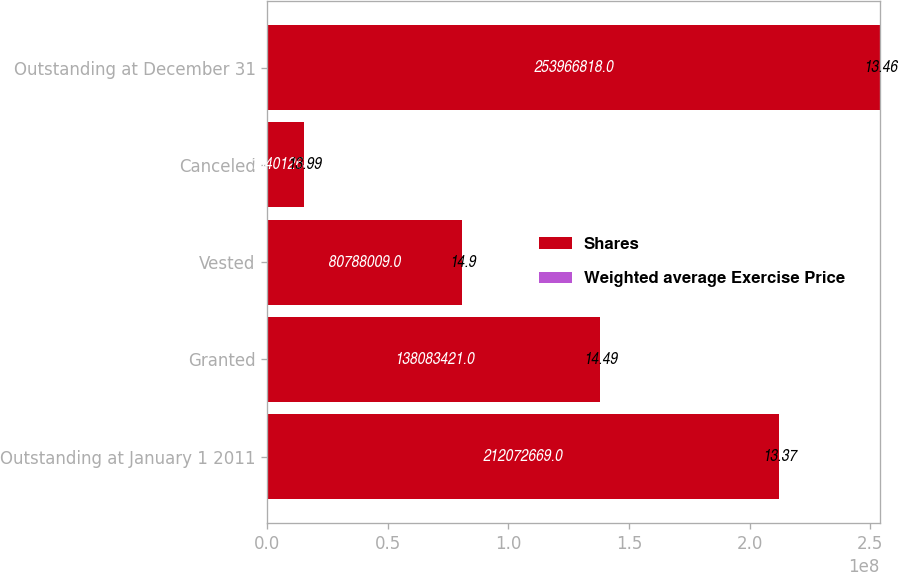Convert chart to OTSL. <chart><loc_0><loc_0><loc_500><loc_500><stacked_bar_chart><ecel><fcel>Outstanding at January 1 2011<fcel>Granted<fcel>Vested<fcel>Canceled<fcel>Outstanding at December 31<nl><fcel>Shares<fcel>2.12073e+08<fcel>1.38083e+08<fcel>8.0788e+07<fcel>1.54013e+07<fcel>2.53967e+08<nl><fcel>Weighted average Exercise Price<fcel>13.37<fcel>14.49<fcel>14.9<fcel>13.99<fcel>13.46<nl></chart> 